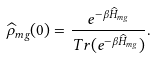Convert formula to latex. <formula><loc_0><loc_0><loc_500><loc_500>\widehat { \rho } _ { m g } ( 0 ) = \frac { e ^ { - \beta \widehat { H } _ { m g } } } { T r ( e ^ { - \beta \widehat { H } _ { m g } } ) } .</formula> 